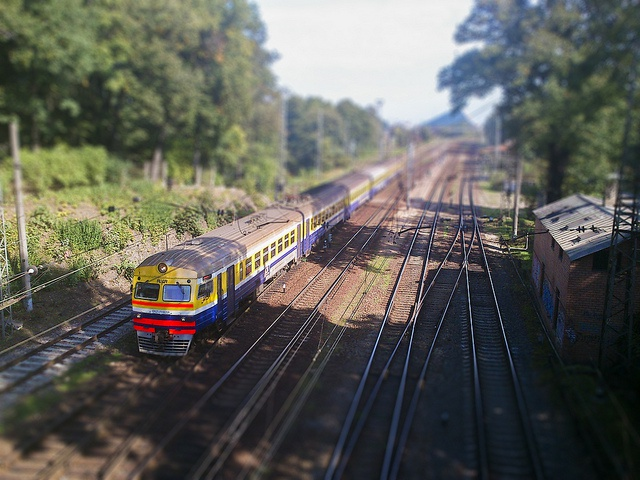Describe the objects in this image and their specific colors. I can see a train in olive, darkgray, black, gray, and tan tones in this image. 